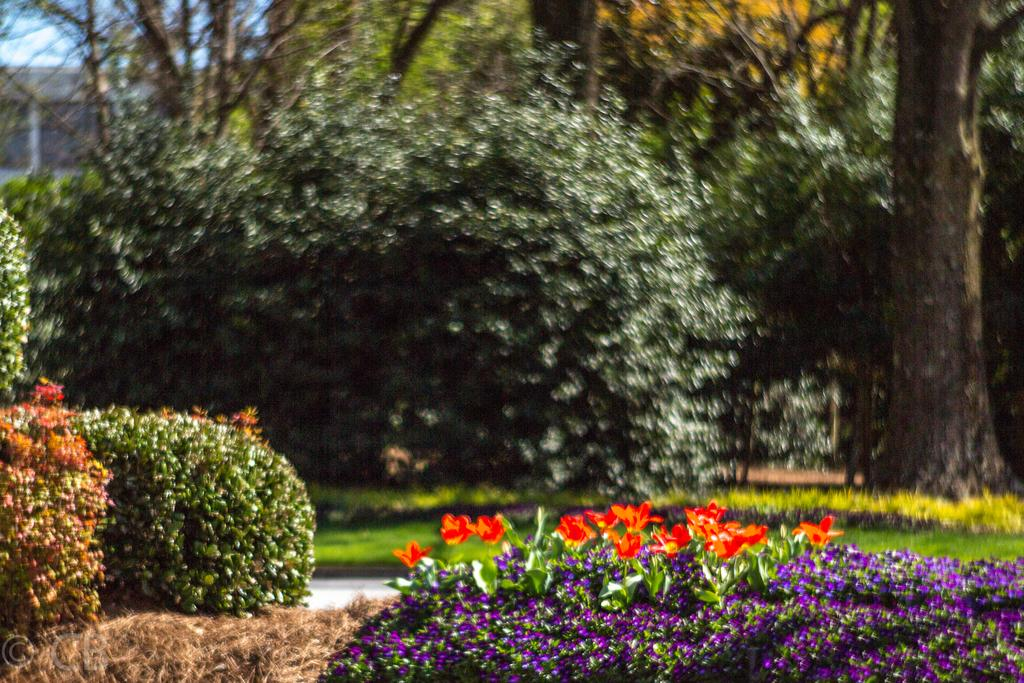What type of vegetation can be seen in the image? There are flowers and plants in the image. What can be seen in the background of the image? There are trees, at least one building, grass, and the sky visible in the background of the image. How is the background of the image depicted? The background of the image is blurred. What key is used to unlock the door in the image? There is no door or key present in the image; it features flowers, plants, and a blurred background. 